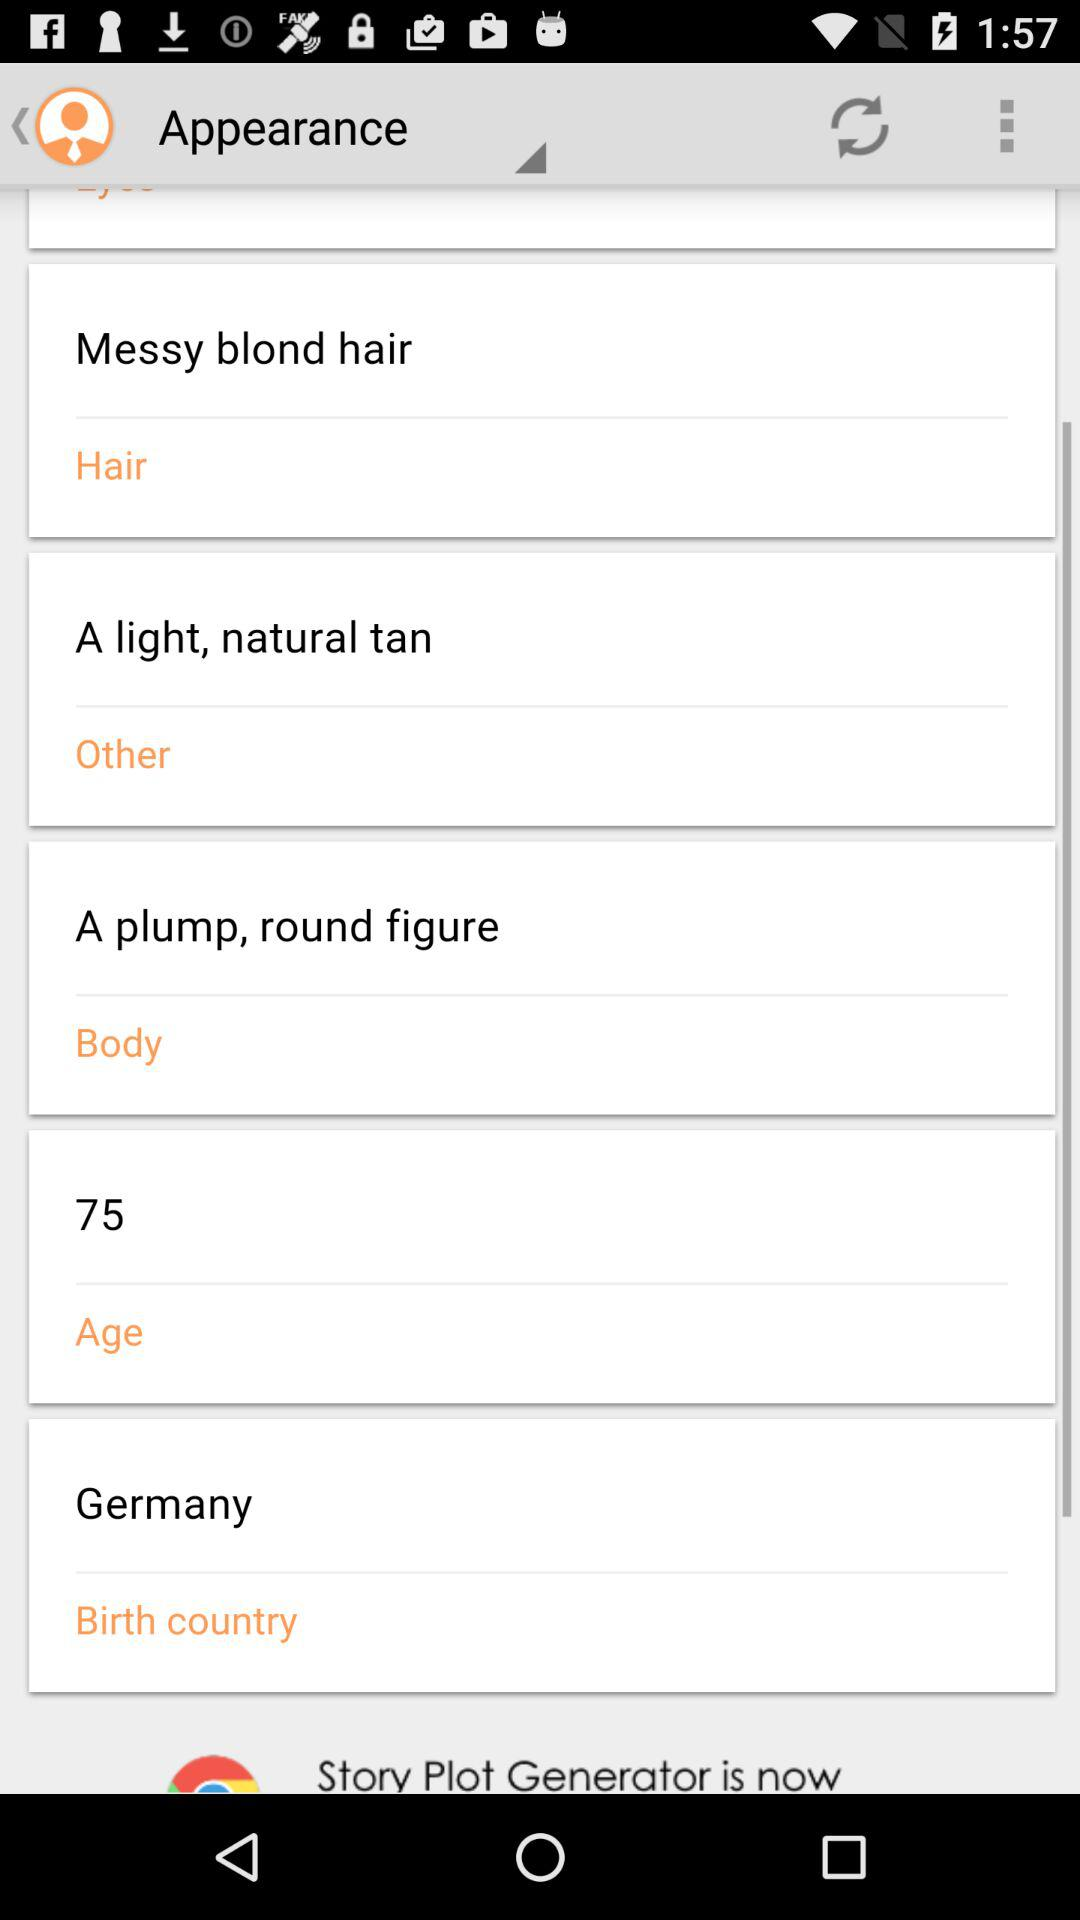What is the hair color? The hair color is messy blond hair. 